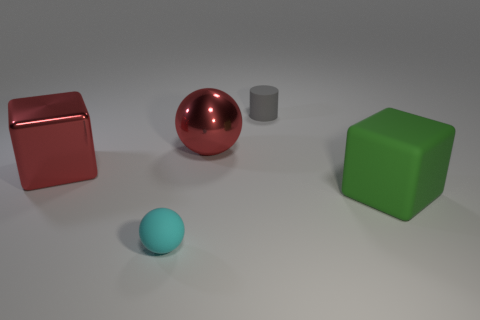How many rubber things are behind the small cyan sphere and in front of the gray matte cylinder?
Your answer should be very brief. 1. What number of other things are the same color as the cylinder?
Ensure brevity in your answer.  0. What shape is the thing that is right of the gray matte cylinder?
Keep it short and to the point. Cube. Are the green cube and the tiny gray thing made of the same material?
Your answer should be very brief. Yes. Is there any other thing that has the same size as the green matte cube?
Provide a succinct answer. Yes. There is a gray matte cylinder; how many gray cylinders are in front of it?
Offer a terse response. 0. There is a tiny object that is in front of the small rubber thing that is behind the green block; what is its shape?
Provide a short and direct response. Sphere. Is there any other thing that is the same shape as the gray object?
Your response must be concise. No. Is the number of red balls that are in front of the big red sphere greater than the number of blocks?
Offer a terse response. No. There is a large red metallic object that is to the left of the big metallic sphere; how many small gray rubber objects are on the right side of it?
Give a very brief answer. 1. 